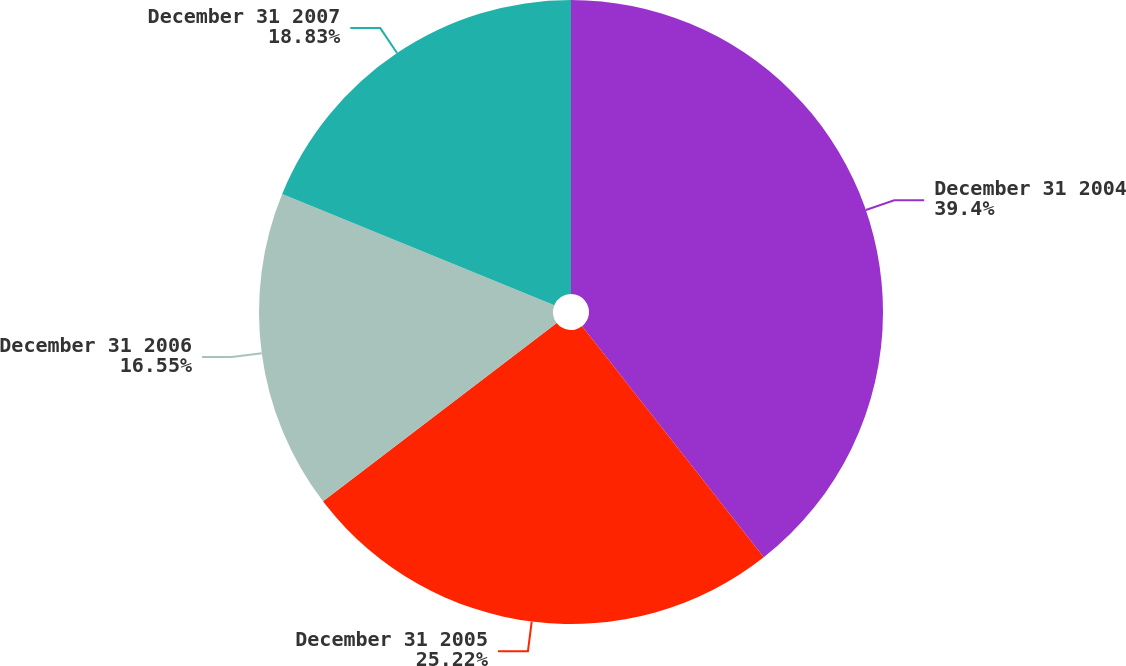Convert chart to OTSL. <chart><loc_0><loc_0><loc_500><loc_500><pie_chart><fcel>December 31 2004<fcel>December 31 2005<fcel>December 31 2006<fcel>December 31 2007<nl><fcel>39.4%<fcel>25.22%<fcel>16.55%<fcel>18.83%<nl></chart> 